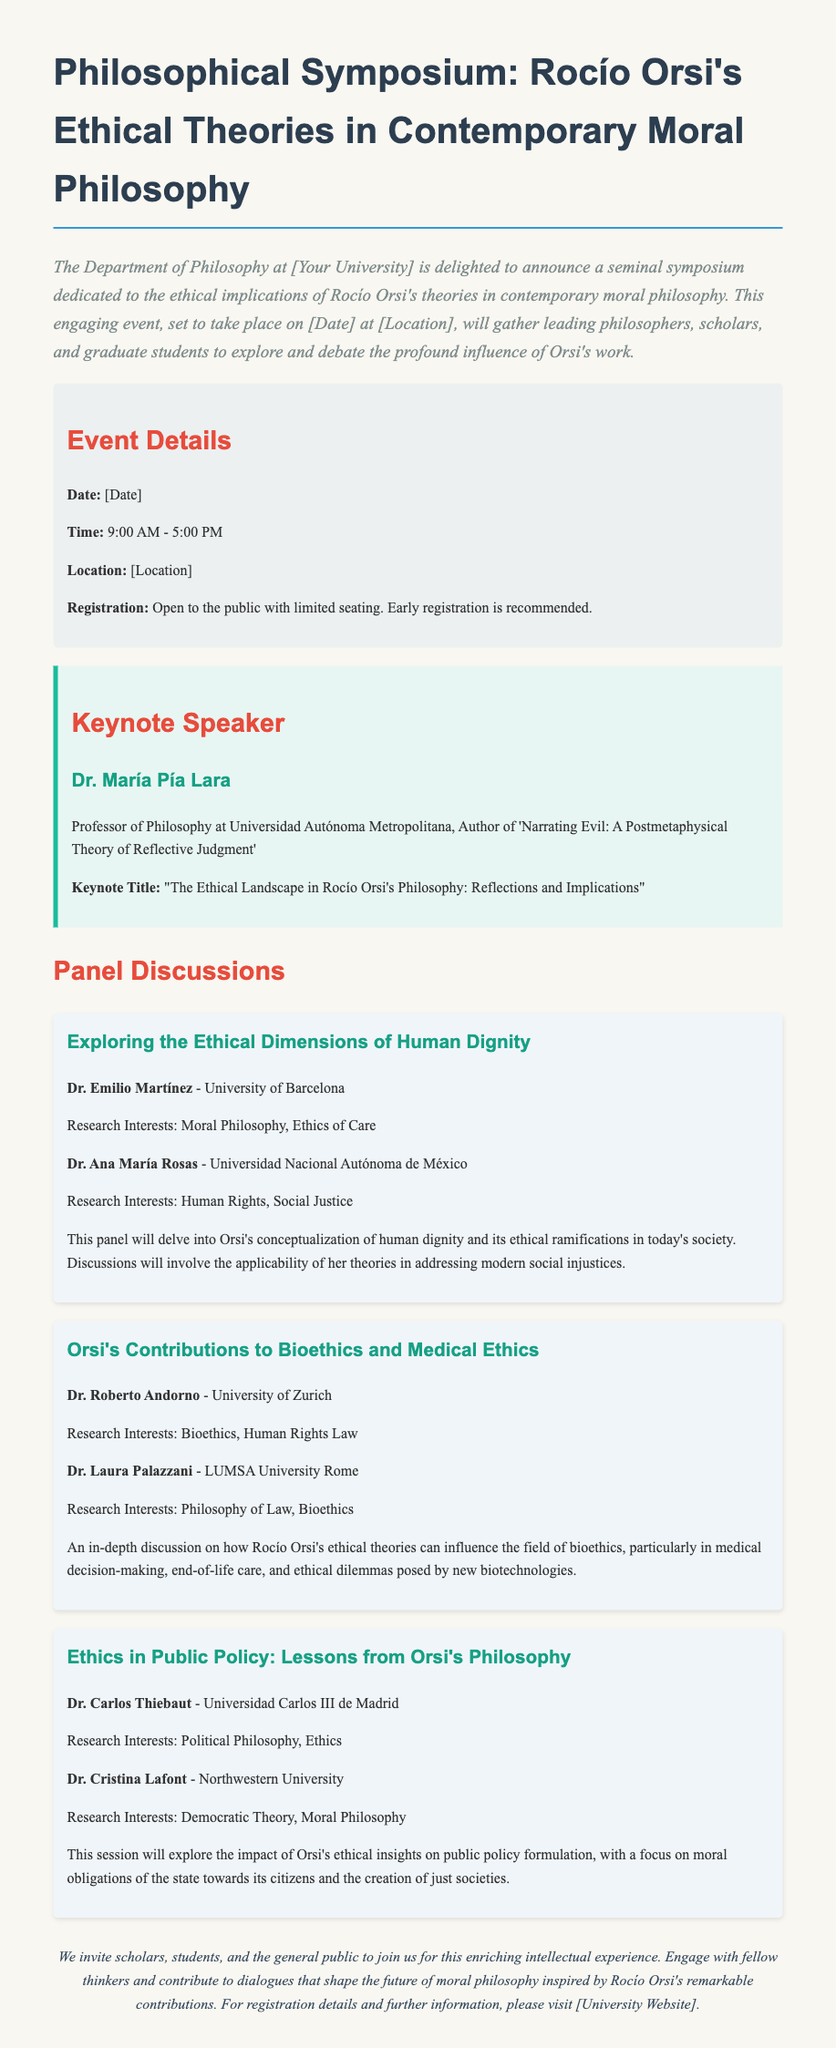What is the date of the symposium? The symposium is set to take place on [Date] as mentioned in the event details section of the document.
Answer: [Date] Who is the keynote speaker? The keynote speaker is Dr. María Pía Lara, as stated in the keynote section of the document.
Answer: Dr. María Pía Lara What is the title of the keynote speech? The title of the keynote speech is "The Ethical Landscape in Rocío Orsi's Philosophy: Reflections and Implications," which can be found in the keynote section.
Answer: "The Ethical Landscape in Rocío Orsi's Philosophy: Reflections and Implications" How many panel discussions are mentioned? There are three panel discussions outlined in the document, indicated by the presence of headings for each panel.
Answer: 3 What topic does the first panel discussion cover? The first panel discussion is about "Exploring the Ethical Dimensions of Human Dignity," as presented in its heading.
Answer: Exploring the Ethical Dimensions of Human Dignity What is a focus of the second panel discussion? The second panel discussion focuses on "Orsi's Contributions to Bioethics and Medical Ethics," highlighted in the panel's title.
Answer: Orsi's Contributions to Bioethics and Medical Ethics Which university is Dr. Emilio Martínez affiliated with? Dr. Emilio Martínez is affiliated with the University of Barcelona, as mentioned under his name in the participant section.
Answer: University of Barcelona What does the symposium invite people to do? The symposium invites scholars, students, and the general public to join for this enriching intellectual experience, which is stated in the closing paragraph.
Answer: Join for this enriching intellectual experience What are the registration details for the symposium? The registration details specify that it is open to the public with limited seating and early registration is recommended, noted in the event details.
Answer: Open to the public with limited seating 